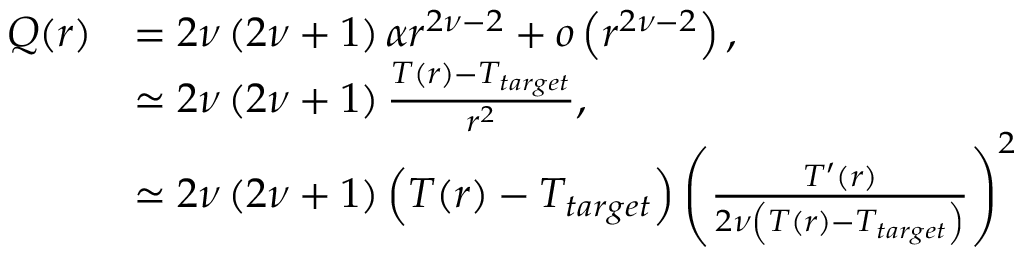Convert formula to latex. <formula><loc_0><loc_0><loc_500><loc_500>\begin{array} { r l } { Q ( r ) } & { = 2 \nu \left ( 2 \nu + 1 \right ) \alpha r ^ { 2 \nu - 2 } + o \left ( r ^ { 2 \nu - 2 } \right ) , } \\ & { \simeq 2 \nu \left ( 2 \nu + 1 \right ) \frac { T ( r ) - T _ { t \arg e t } } { r ^ { 2 } } , } \\ & { \simeq 2 \nu \left ( 2 \nu + 1 \right ) \left ( T ( r ) - T _ { t \arg e t } \right ) \left ( \frac { T ^ { \prime } ( r ) } { 2 \nu \left ( T ( r ) - T _ { t \arg e t } \right ) } \right ) ^ { 2 } } \end{array}</formula> 